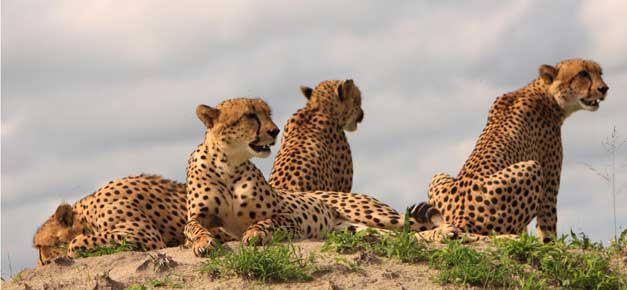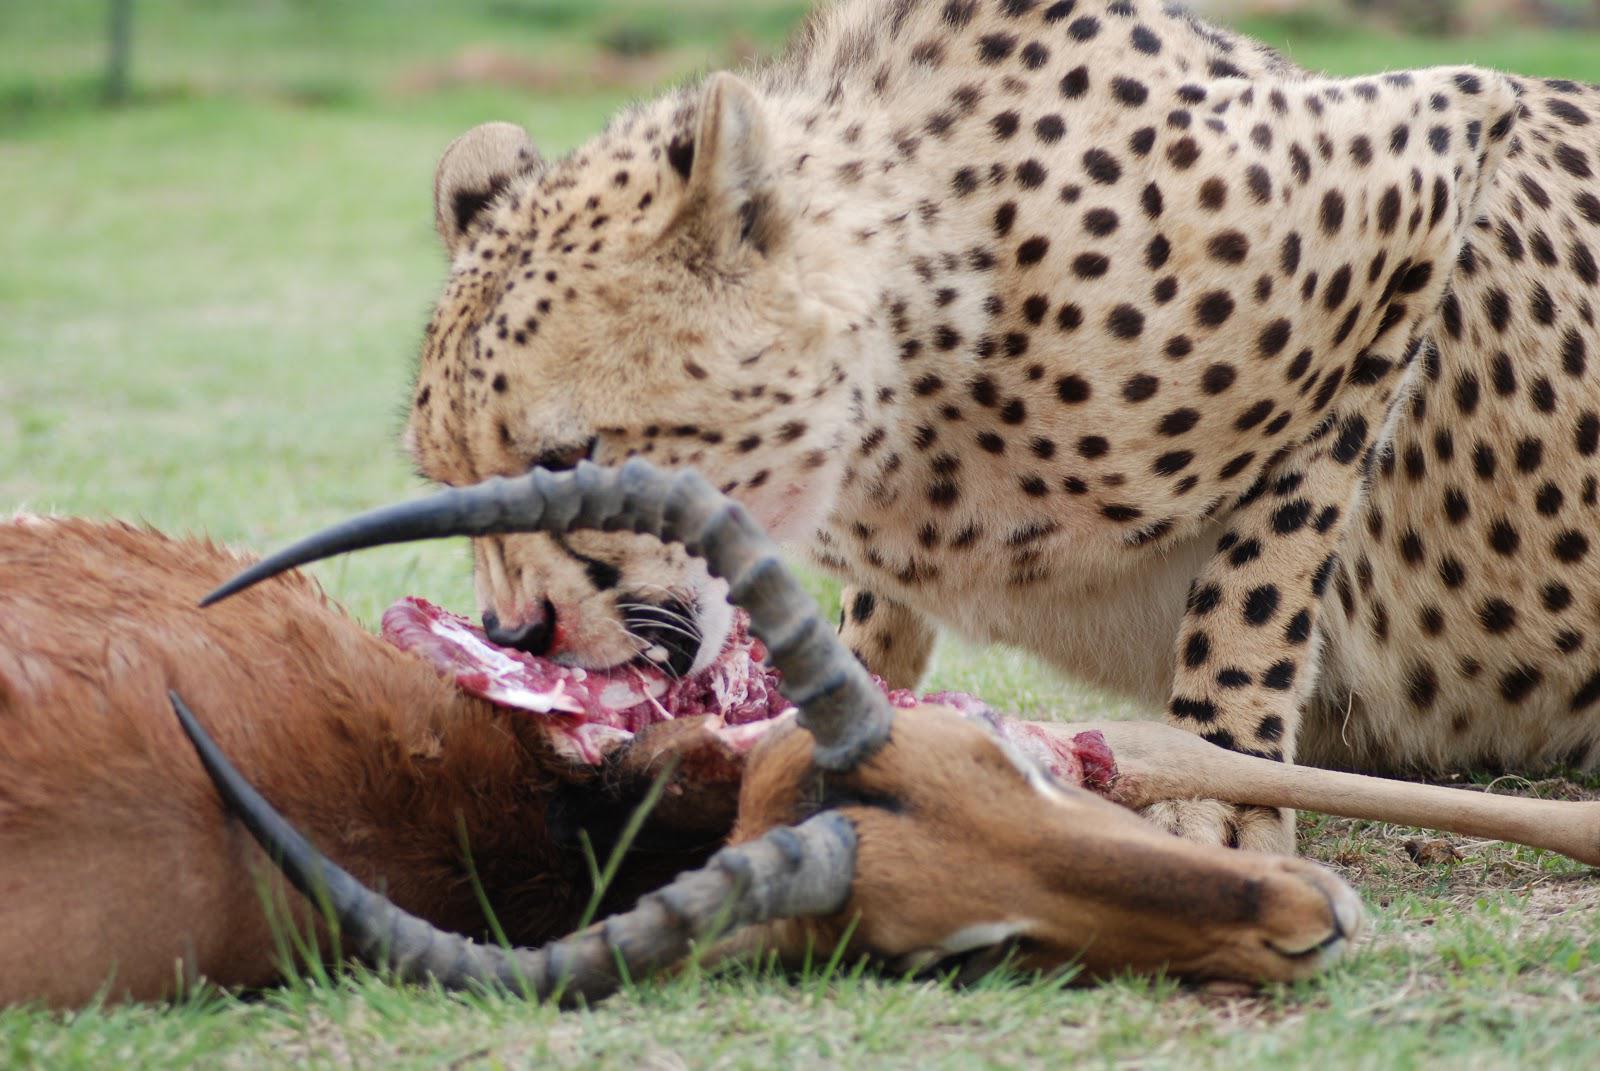The first image is the image on the left, the second image is the image on the right. For the images displayed, is the sentence "An image shows four cheetahs grouped on a dirt mound, with at least one of them reclining." factually correct? Answer yes or no. Yes. 